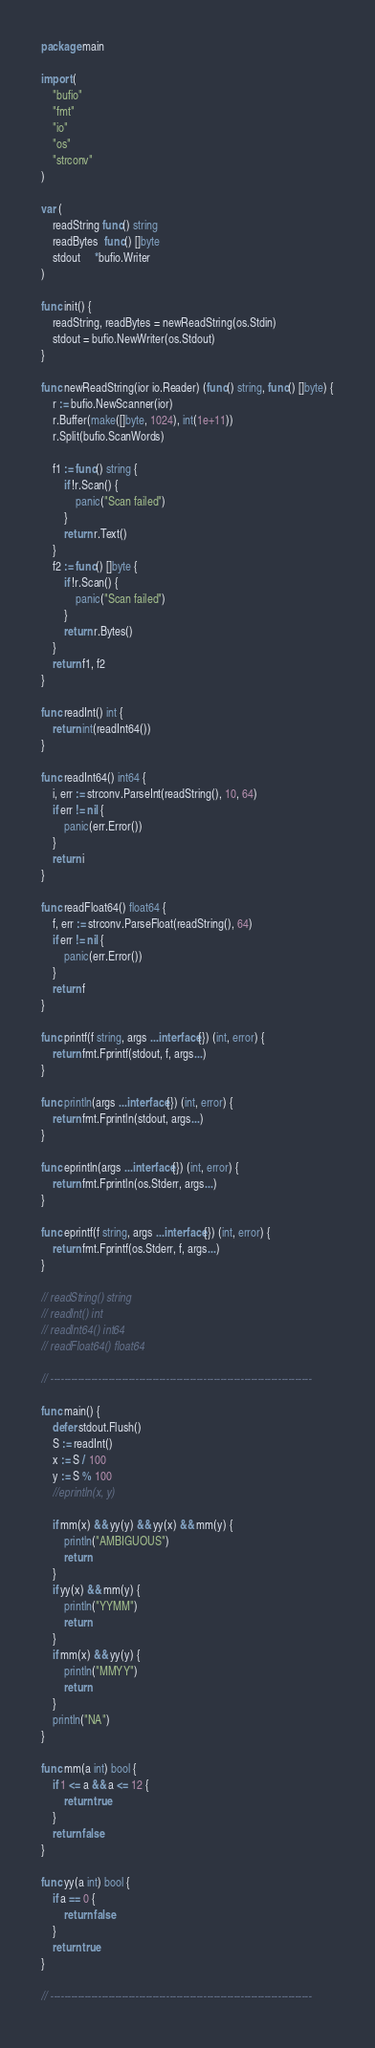<code> <loc_0><loc_0><loc_500><loc_500><_Go_>package main

import (
	"bufio"
	"fmt"
	"io"
	"os"
	"strconv"
)

var (
	readString func() string
	readBytes  func() []byte
	stdout     *bufio.Writer
)

func init() {
	readString, readBytes = newReadString(os.Stdin)
	stdout = bufio.NewWriter(os.Stdout)
}

func newReadString(ior io.Reader) (func() string, func() []byte) {
	r := bufio.NewScanner(ior)
	r.Buffer(make([]byte, 1024), int(1e+11))
	r.Split(bufio.ScanWords)

	f1 := func() string {
		if !r.Scan() {
			panic("Scan failed")
		}
		return r.Text()
	}
	f2 := func() []byte {
		if !r.Scan() {
			panic("Scan failed")
		}
		return r.Bytes()
	}
	return f1, f2
}

func readInt() int {
	return int(readInt64())
}

func readInt64() int64 {
	i, err := strconv.ParseInt(readString(), 10, 64)
	if err != nil {
		panic(err.Error())
	}
	return i
}

func readFloat64() float64 {
	f, err := strconv.ParseFloat(readString(), 64)
	if err != nil {
		panic(err.Error())
	}
	return f
}

func printf(f string, args ...interface{}) (int, error) {
	return fmt.Fprintf(stdout, f, args...)
}

func println(args ...interface{}) (int, error) {
	return fmt.Fprintln(stdout, args...)
}

func eprintln(args ...interface{}) (int, error) {
	return fmt.Fprintln(os.Stderr, args...)
}

func eprintf(f string, args ...interface{}) (int, error) {
	return fmt.Fprintf(os.Stderr, f, args...)
}

// readString() string
// readInt() int
// readInt64() int64
// readFloat64() float64

// -----------------------------------------------------------------------------

func main() {
	defer stdout.Flush()
	S := readInt()
	x := S / 100
	y := S % 100
	//eprintln(x, y)

	if mm(x) && yy(y) && yy(x) && mm(y) {
		println("AMBIGUOUS")
		return
	}
	if yy(x) && mm(y) {
		println("YYMM")
		return
	}
	if mm(x) && yy(y) {
		println("MMYY")
		return
	}
	println("NA")
}

func mm(a int) bool {
	if 1 <= a && a <= 12 {
		return true
	}
	return false
}

func yy(a int) bool {
	if a == 0 {
		return false
	}
	return true
}

// -----------------------------------------------------------------------------
</code> 